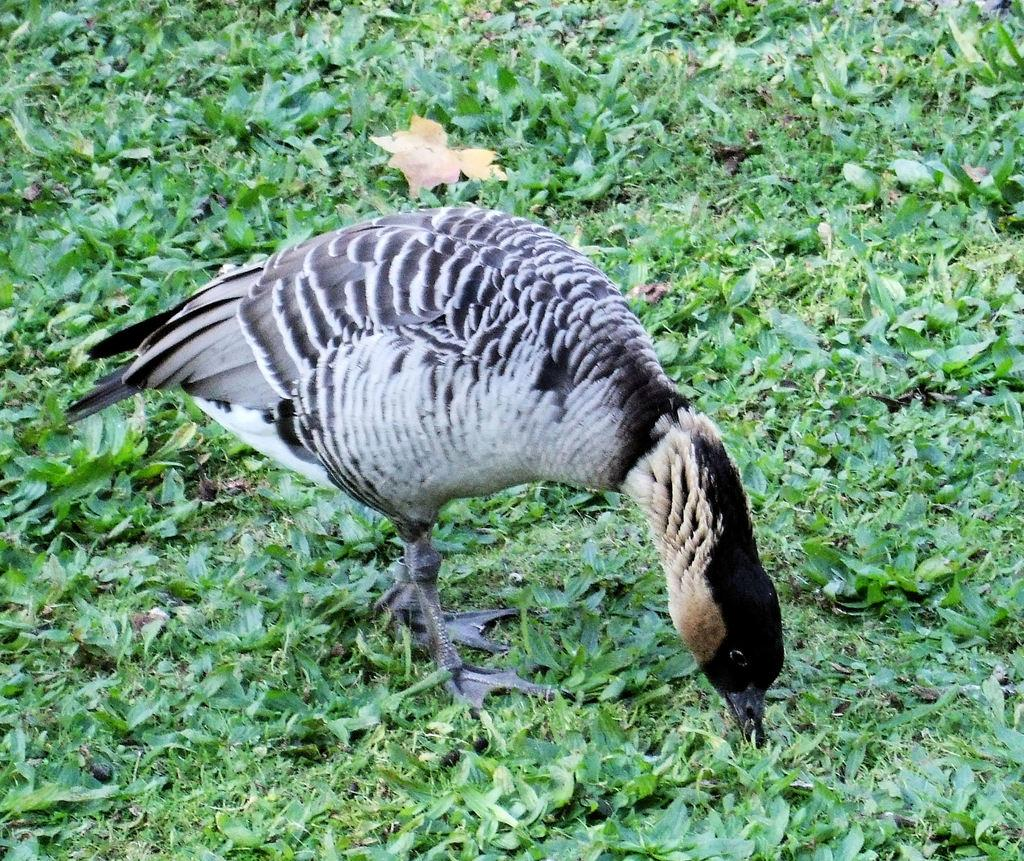What type of animal is present in the image? There is a bird in the image. What is the bird doing in the image? The bird is eating leaves in the image. What else can be seen in the image besides the bird? There are plants in the image. How does the bird increase the number of leaves in the image? The bird does not increase the number of leaves in the image; it is eating them. 